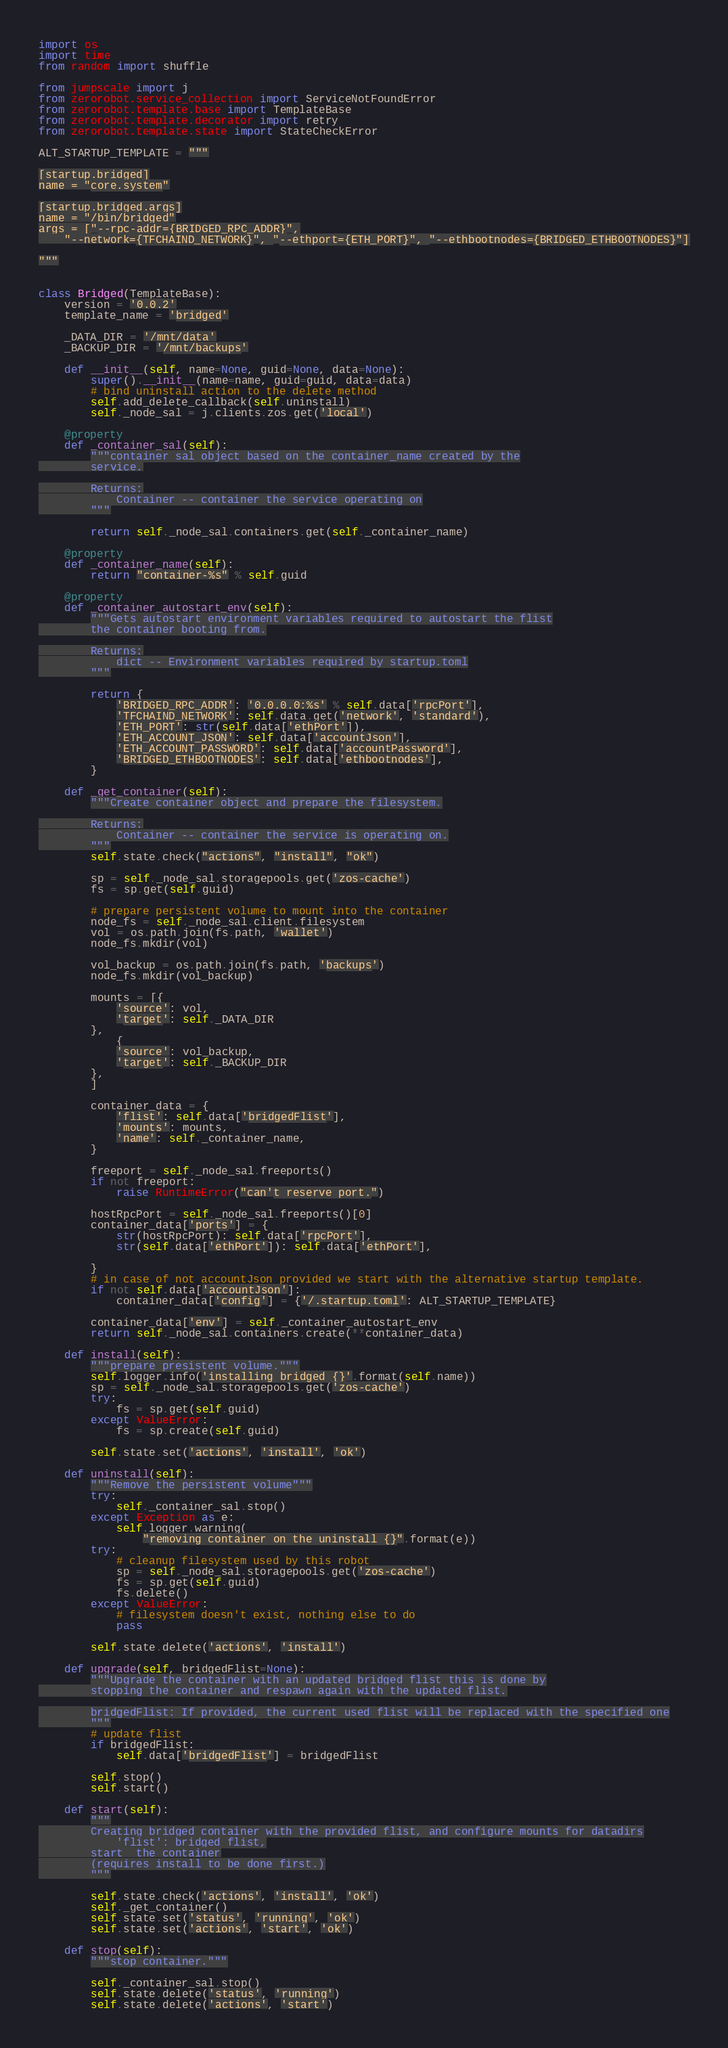<code> <loc_0><loc_0><loc_500><loc_500><_Python_>import os
import time
from random import shuffle

from jumpscale import j
from zerorobot.service_collection import ServiceNotFoundError
from zerorobot.template.base import TemplateBase
from zerorobot.template.decorator import retry
from zerorobot.template.state import StateCheckError

ALT_STARTUP_TEMPLATE = """

[startup.bridged]
name = "core.system"

[startup.bridged.args]
name = "/bin/bridged"
args = ["--rpc-addr={BRIDGED_RPC_ADDR}",
    "--network={TFCHAIND_NETWORK}", "--ethport={ETH_PORT}", "--ethbootnodes={BRIDGED_ETHBOOTNODES}"]

"""


class Bridged(TemplateBase):
    version = '0.0.2'
    template_name = 'bridged'

    _DATA_DIR = '/mnt/data'
    _BACKUP_DIR = '/mnt/backups'

    def __init__(self, name=None, guid=None, data=None):
        super().__init__(name=name, guid=guid, data=data)
        # bind uninstall action to the delete method
        self.add_delete_callback(self.uninstall)
        self._node_sal = j.clients.zos.get('local')

    @property
    def _container_sal(self):
        """container sal object based on the container_name created by the
        service.

        Returns:
            Container -- container the service operating on
        """

        return self._node_sal.containers.get(self._container_name)

    @property
    def _container_name(self):
        return "container-%s" % self.guid

    @property
    def _container_autostart_env(self):
        """Gets autostart environment variables required to autostart the flist
        the container booting from.

        Returns:
            dict -- Environment variables required by startup.toml
        """

        return {
            'BRIDGED_RPC_ADDR': '0.0.0.0:%s' % self.data['rpcPort'],
            'TFCHAIND_NETWORK': self.data.get('network', 'standard'),
            'ETH_PORT': str(self.data['ethPort']),
            'ETH_ACCOUNT_JSON': self.data['accountJson'],
            'ETH_ACCOUNT_PASSWORD': self.data['accountPassword'],
            'BRIDGED_ETHBOOTNODES': self.data['ethbootnodes'],
        }

    def _get_container(self):
        """Create container object and prepare the filesystem.

        Returns:
            Container -- container the service is operating on.
        """
        self.state.check("actions", "install", "ok")

        sp = self._node_sal.storagepools.get('zos-cache')
        fs = sp.get(self.guid)

        # prepare persistent volume to mount into the container
        node_fs = self._node_sal.client.filesystem
        vol = os.path.join(fs.path, 'wallet')
        node_fs.mkdir(vol)

        vol_backup = os.path.join(fs.path, 'backups')
        node_fs.mkdir(vol_backup)

        mounts = [{
            'source': vol,
            'target': self._DATA_DIR
        },
            {
            'source': vol_backup,
            'target': self._BACKUP_DIR
        },
        ]

        container_data = {
            'flist': self.data['bridgedFlist'],
            'mounts': mounts,
            'name': self._container_name,
        }

        freeport = self._node_sal.freeports()
        if not freeport:
            raise RuntimeError("can't reserve port.")

        hostRpcPort = self._node_sal.freeports()[0]
        container_data['ports'] = {
            str(hostRpcPort): self.data['rpcPort'],
            str(self.data['ethPort']): self.data['ethPort'],

        }
        # in case of not accountJson provided we start with the alternative startup template.
        if not self.data['accountJson']:
            container_data['config'] = {'/.startup.toml': ALT_STARTUP_TEMPLATE}

        container_data['env'] = self._container_autostart_env
        return self._node_sal.containers.create(**container_data)

    def install(self):
        """prepare presistent volume."""
        self.logger.info('installing bridged {}'.format(self.name))
        sp = self._node_sal.storagepools.get('zos-cache')
        try:
            fs = sp.get(self.guid)
        except ValueError:
            fs = sp.create(self.guid)

        self.state.set('actions', 'install', 'ok')

    def uninstall(self):
        """Remove the persistent volume"""
        try:
            self._container_sal.stop()
        except Exception as e:
            self.logger.warning(
                "removing container on the uninstall {}".format(e))
        try:
            # cleanup filesystem used by this robot
            sp = self._node_sal.storagepools.get('zos-cache')
            fs = sp.get(self.guid)
            fs.delete()
        except ValueError:
            # filesystem doesn't exist, nothing else to do
            pass

        self.state.delete('actions', 'install')

    def upgrade(self, bridgedFlist=None):
        """Upgrade the container with an updated bridged flist this is done by
        stopping the container and respawn again with the updated flist.

        bridgedFlist: If provided, the current used flist will be replaced with the specified one
        """
        # update flist
        if bridgedFlist:
            self.data['bridgedFlist'] = bridgedFlist

        self.stop()
        self.start()

    def start(self):
        """
        Creating bridged container with the provided flist, and configure mounts for datadirs
            'flist': bridged flist,
        start  the container
        (requires install to be done first.)
        """

        self.state.check('actions', 'install', 'ok')
        self._get_container()
        self.state.set('status', 'running', 'ok')
        self.state.set('actions', 'start', 'ok')

    def stop(self):
        """stop container."""

        self._container_sal.stop()
        self.state.delete('status', 'running')
        self.state.delete('actions', 'start')
</code> 